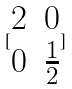Convert formula to latex. <formula><loc_0><loc_0><loc_500><loc_500>[ \begin{matrix} 2 & 0 \\ 0 & \frac { 1 } { 2 } \end{matrix} ]</formula> 